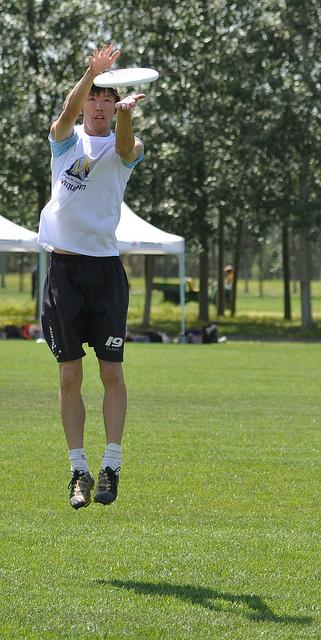Does this area look like a public park?
Short answer required. Yes. Were any of the man's feet or hands in contact with anything at the moment of the photo?
Concise answer only. No. What is the man catching?
Answer briefly. Frisbee. What sport is this?
Quick response, please. Frisbee. 